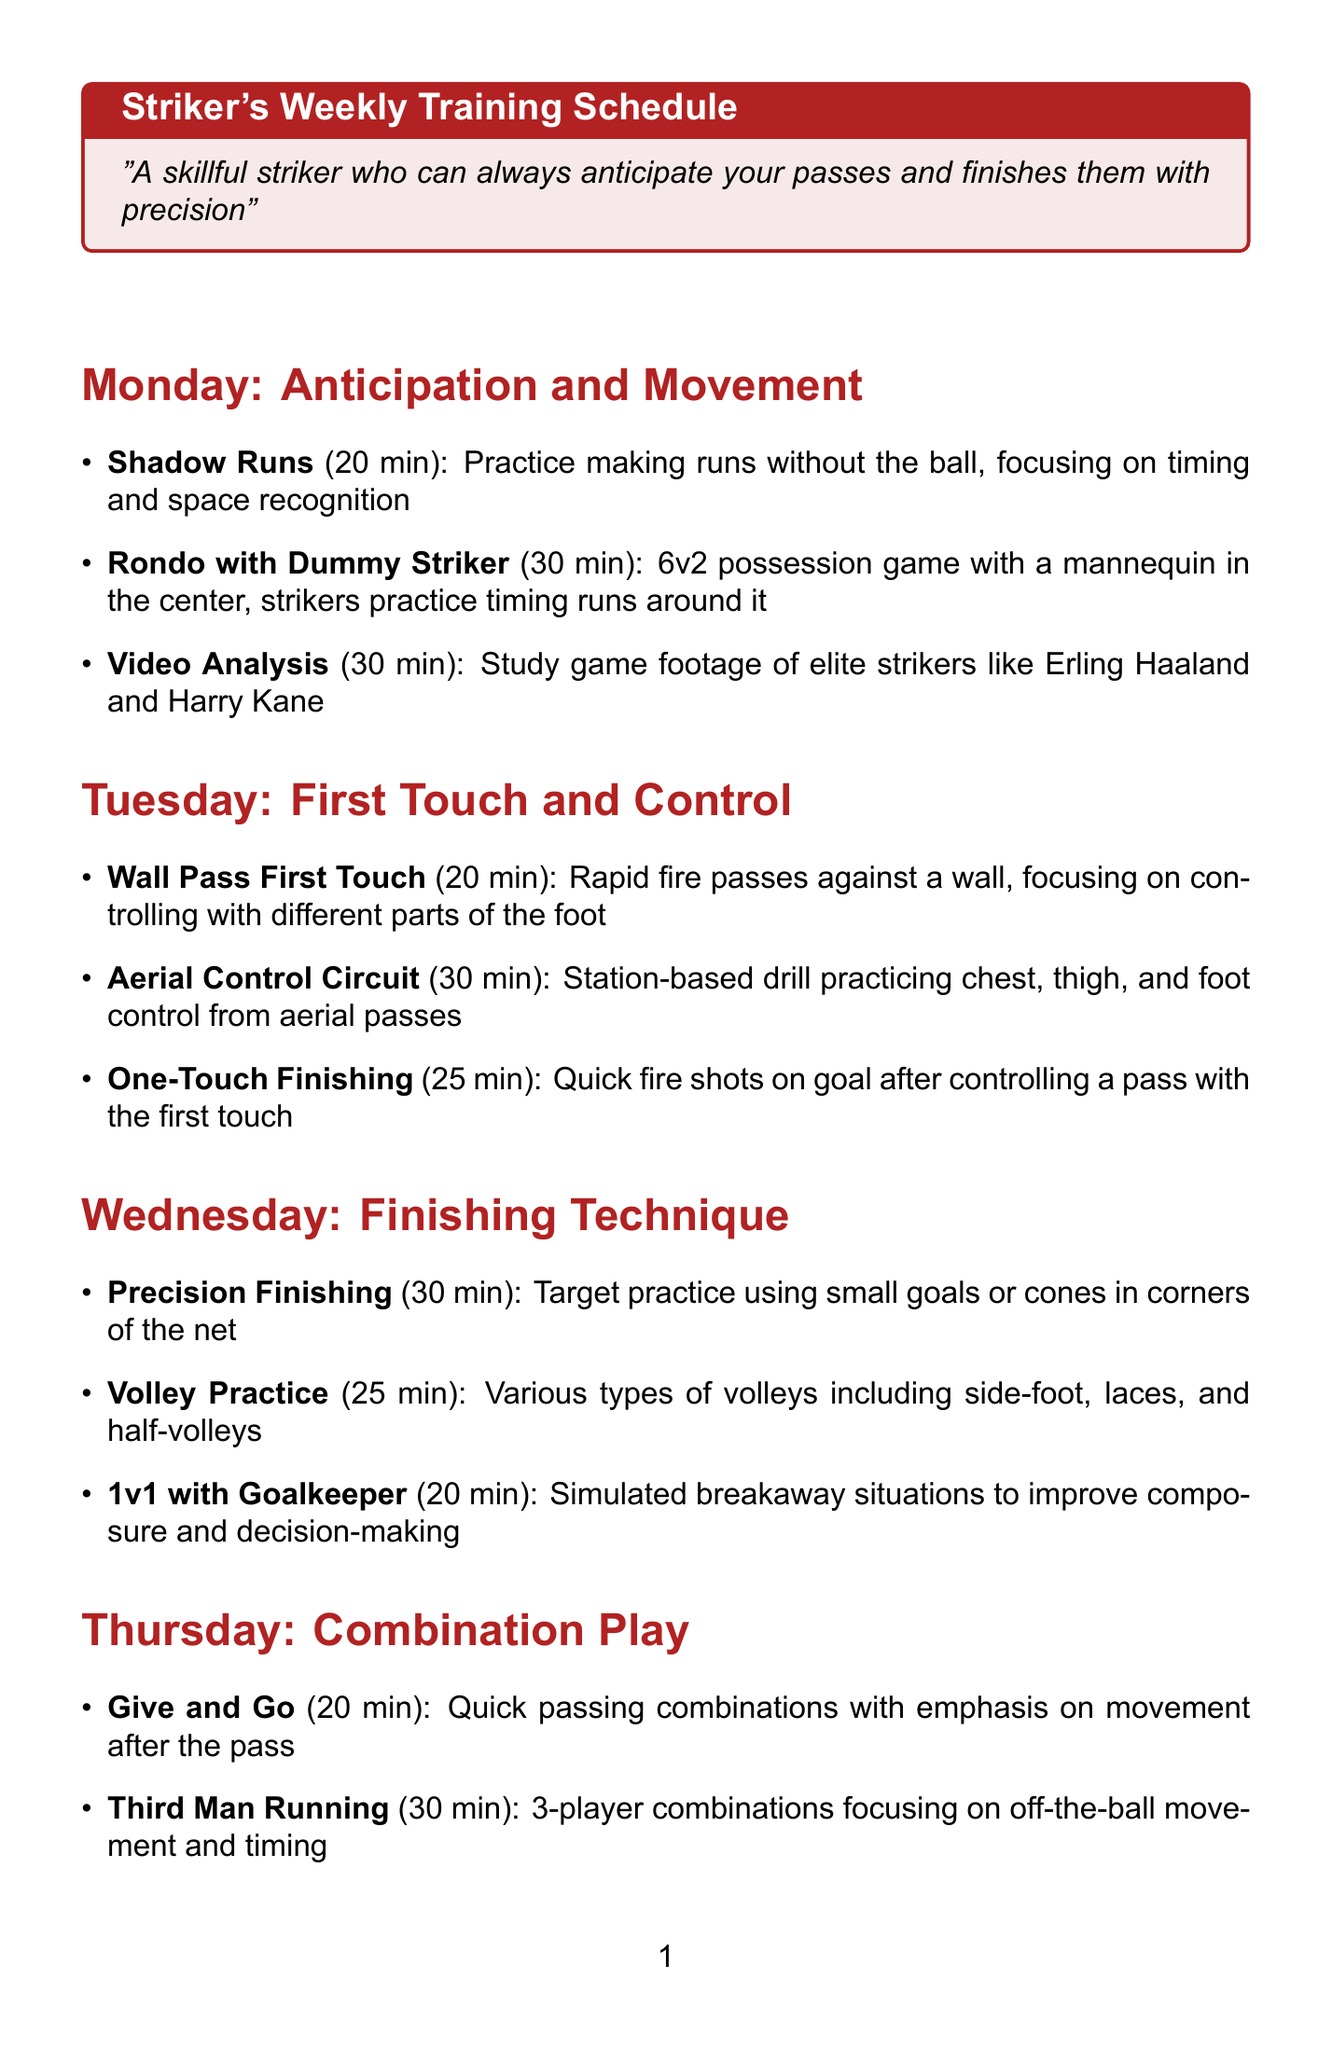What is the focus for Monday? The focus for Monday is mentioned at the beginning of the section titled "Monday: Anticipation and Movement."
Answer: Anticipation and Movement How long is the "1v1 with Goalkeeper" drill? The duration for the "1v1 with Goalkeeper" drill is specified in the Wednesday section.
Answer: 20 minutes What equipment is needed for the training? The equipment needed is listed at the top under "equipment_needed."
Answer: Soccer balls How many drills are scheduled for Thursday? To determine this, count the number of drills listed under the Thursday section.
Answer: 3 What type of game is practiced on Saturday? The activity specified on Saturday is described in the "Match or High-Intensity Training" section.
Answer: Full-Sided Match Which day focuses on "First Touch and Control"? The day related to "First Touch and Control" is clearly stated in the document.
Answer: Tuesday What is the duration of the "Pressure Finishing" drill? The exact duration of the "Pressure Finishing" drill is mentioned within the Friday section.
Answer: 30 minutes What is practiced on Sunday for recovery? The drills for recovery are listed under "Recovery and Mental Preparation."
Answer: Light Jog and Stretching How is "Video Analysis" used in the training? The "Video Analysis" drill's purpose is stated in the Monday section of the schedule.
Answer: Study game footage 